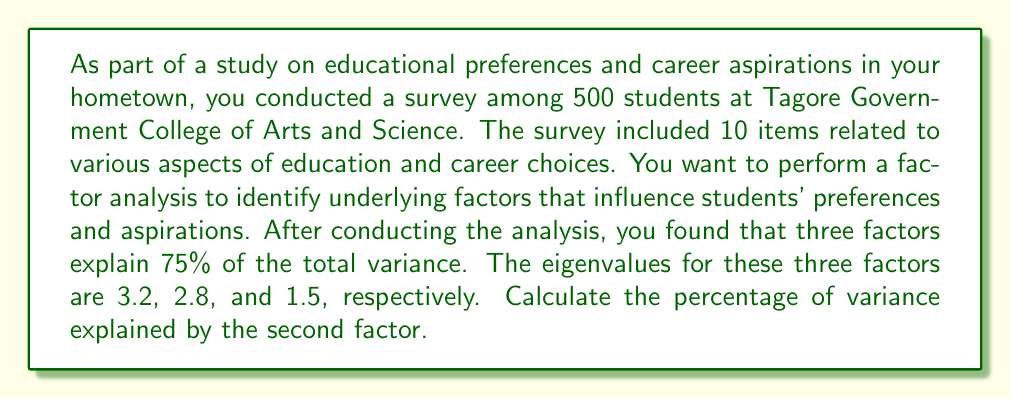Can you answer this question? To solve this problem, we need to follow these steps:

1. Understand the concept of eigenvalues in factor analysis:
   Eigenvalues represent the amount of variance explained by each factor.

2. Calculate the total variance explained by the three factors:
   Total variance = Sum of eigenvalues
   $$ \text{Total variance} = 3.2 + 2.8 + 1.5 = 7.5 $$

3. Calculate the proportion of variance explained by the second factor:
   $$ \text{Proportion} = \frac{\text{Eigenvalue of second factor}}{\text{Total variance}} $$
   $$ \text{Proportion} = \frac{2.8}{7.5} = 0.3733 $$

4. Convert the proportion to a percentage:
   $$ \text{Percentage} = \text{Proportion} \times 100\% $$
   $$ \text{Percentage} = 0.3733 \times 100\% = 37.33\% $$

Therefore, the second factor explains 37.33% of the total variance.
Answer: 37.33% 